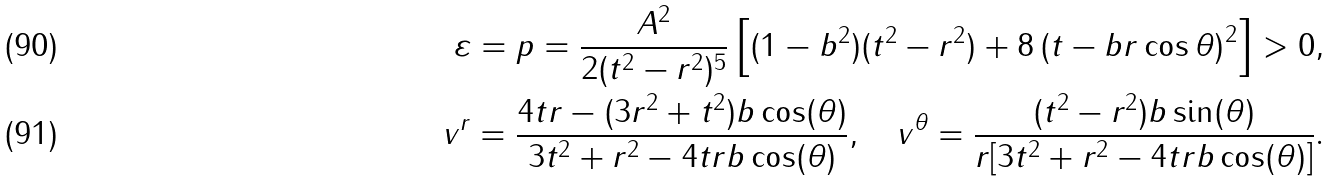<formula> <loc_0><loc_0><loc_500><loc_500>\varepsilon = p = \frac { A ^ { 2 } } { 2 ( t ^ { 2 } - r ^ { 2 } ) ^ { 5 } } \left [ { ( 1 - b ^ { 2 } ) ( t ^ { 2 } - r ^ { 2 } ) + 8 \left ( { t - b r \cos \theta } \right ) ^ { 2 } } \right ] > 0 , \\ v ^ { r } = \frac { 4 t r - ( 3 r ^ { 2 } + t ^ { 2 } ) b \cos ( \theta ) } { 3 t ^ { 2 } + r ^ { 2 } - 4 t r b \cos ( \theta ) } , \quad v ^ { \theta } = \frac { ( t ^ { 2 } - r ^ { 2 } ) b \sin ( \theta ) } { r [ 3 t ^ { 2 } + r ^ { 2 } - 4 t r b \cos ( \theta ) ] } .</formula> 